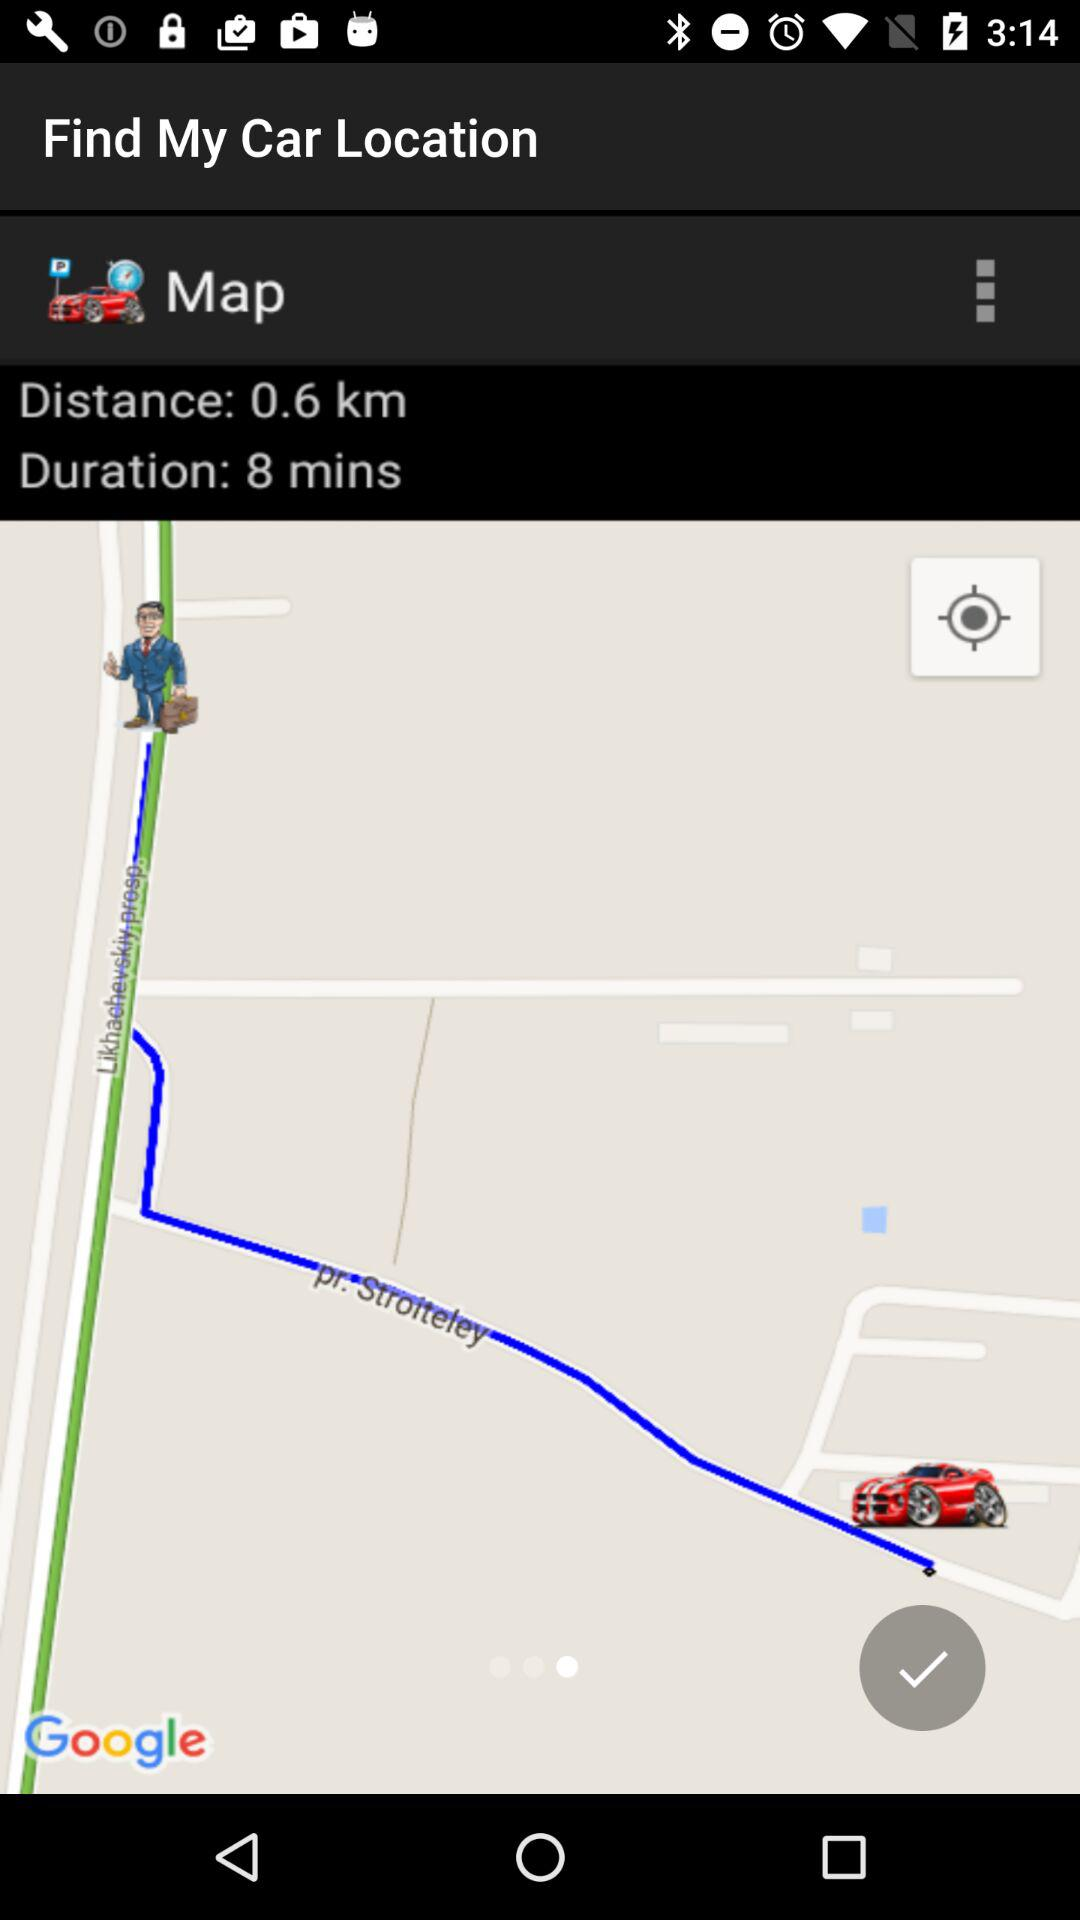What is the distance of the car from my location? The distance is 0.6 km. 